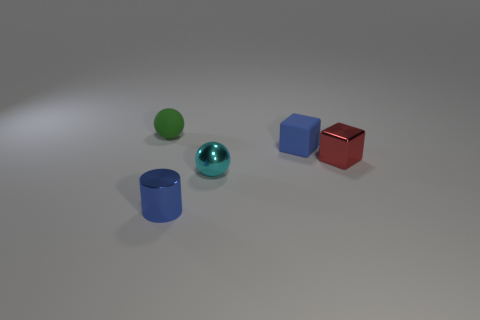What shape is the tiny rubber object in front of the small green rubber object that is to the left of the tiny blue shiny object?
Your response must be concise. Cube. There is a green rubber thing that is to the left of the shiny cylinder; is it the same size as the blue rubber cube?
Make the answer very short. Yes. There is a thing that is both behind the cyan metal thing and in front of the blue block; what size is it?
Provide a short and direct response. Small. What number of other red things have the same size as the red metallic thing?
Offer a very short reply. 0. How many cyan shiny spheres are in front of the tiny metal object in front of the metallic ball?
Ensure brevity in your answer.  0. Is the color of the cube behind the red metallic block the same as the small matte ball?
Your answer should be very brief. No. There is a matte thing on the right side of the small green rubber object left of the matte block; are there any blue matte cubes on the left side of it?
Give a very brief answer. No. There is a tiny metal thing that is both behind the small blue cylinder and in front of the tiny red object; what shape is it?
Your answer should be very brief. Sphere. Is there a big matte thing that has the same color as the matte cube?
Give a very brief answer. No. What color is the rubber object that is on the right side of the tiny blue shiny cylinder in front of the cyan metal thing?
Offer a very short reply. Blue. 